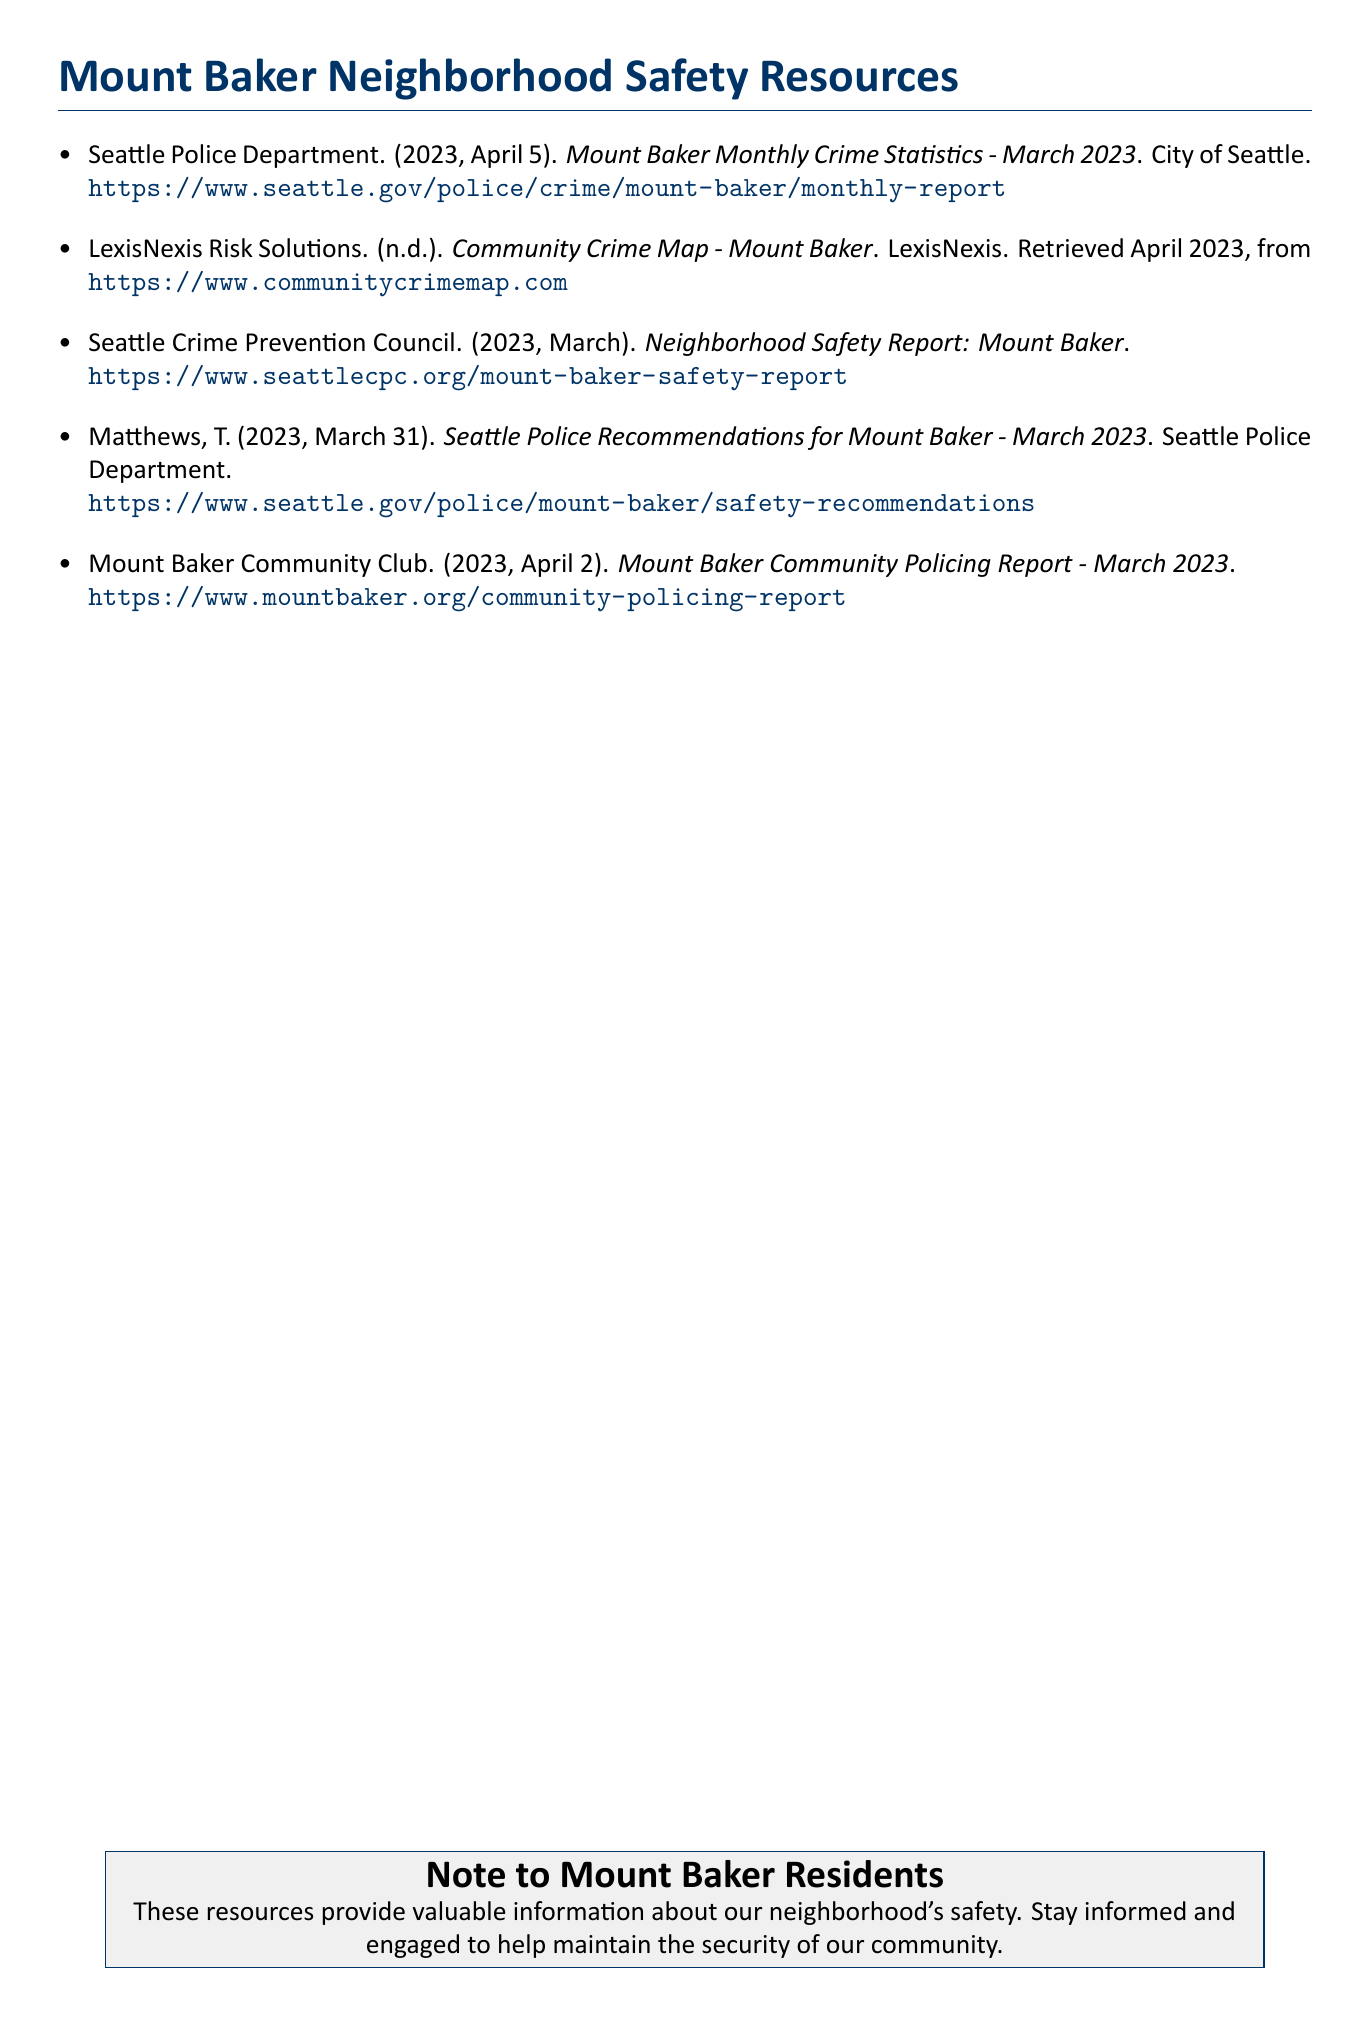what is the title of the first resource? The title of the first resource is provided in the bibliography under the Seattle Police Department entry.
Answer: Mount Baker Monthly Crime Statistics - March 2023 who published the neighborhood safety report? The neighborhood safety report is published by the Seattle Crime Prevention Council.
Answer: Seattle Crime Prevention Council what date was the Mount Baker Community Policing Report released? The date of release is mentioned in the Mount Baker Community Club entry of the bibliography.
Answer: April 2, 2023 which organization offers a community crime map? The organization that offers a community crime map is specified in the second entry of the bibliography.
Answer: LexisNexis Risk Solutions what is the main purpose of the listed resources? The main purpose is highlighted in the note to Mount Baker residents at the end of the document.
Answer: Valuable information about our neighborhood's safety how many resources are listed in the bibliography? The total number of resources can be counted from the items in the bibliography section.
Answer: Five what recommendations were provided by the Seattle Police? The specific recommendations are outlined in a separate document by the Seattle Police Department.
Answer: Seattle Police Recommendations for Mount Baker - March 2023 when was the most recent crime statistics report published? The most recent crime statistics report's publication date is indicated in the first entry.
Answer: April 5, 2023 